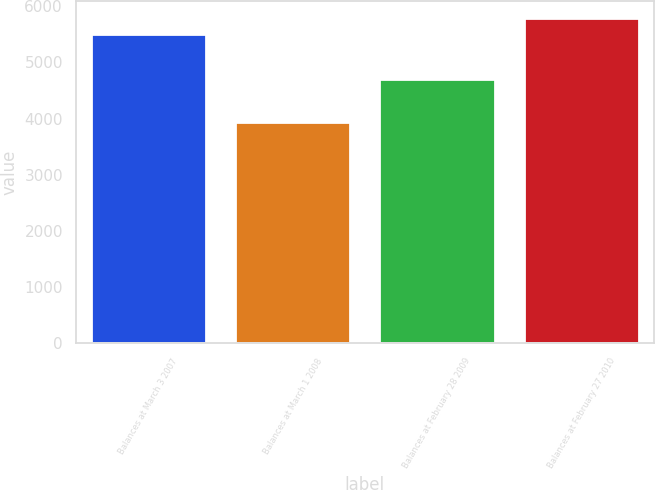Convert chart. <chart><loc_0><loc_0><loc_500><loc_500><bar_chart><fcel>Balances at March 3 2007<fcel>Balances at March 1 2008<fcel>Balances at February 28 2009<fcel>Balances at February 27 2010<nl><fcel>5507<fcel>3933<fcel>4714<fcel>5797<nl></chart> 